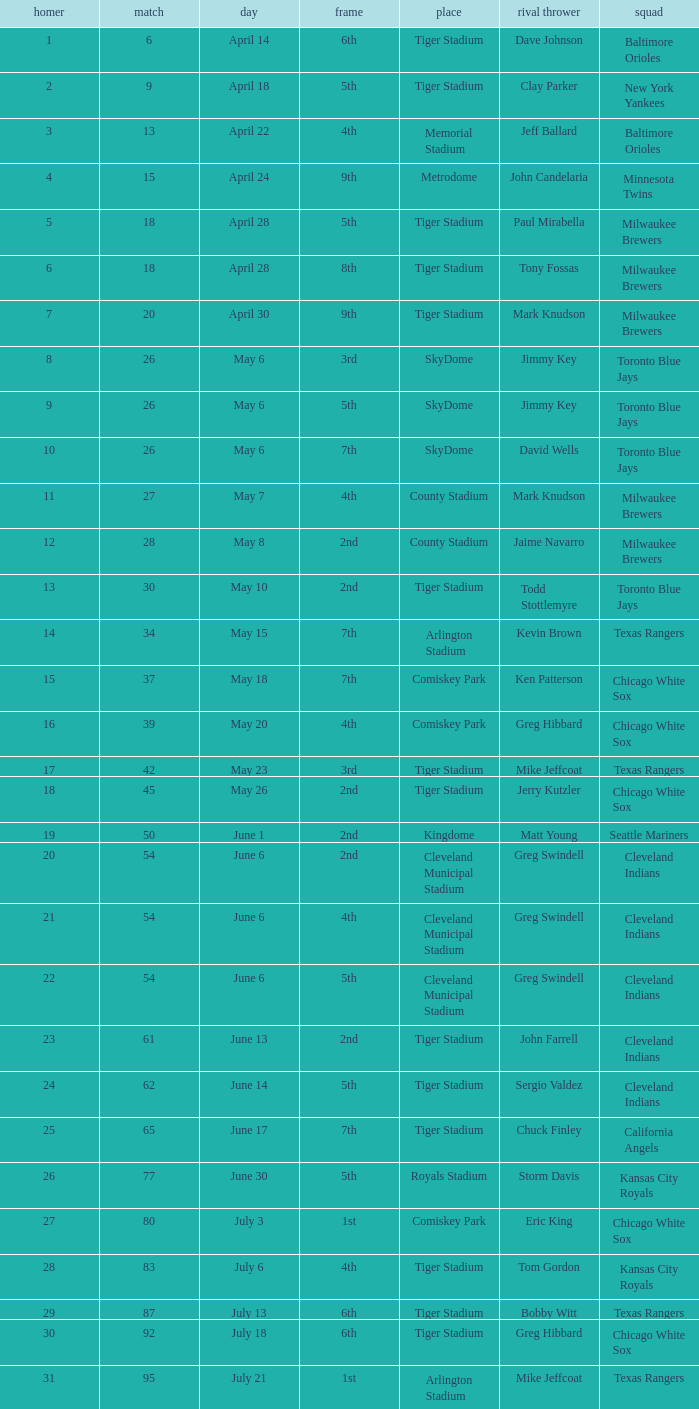On June 17 in Tiger stadium, what was the average home run? 25.0. 